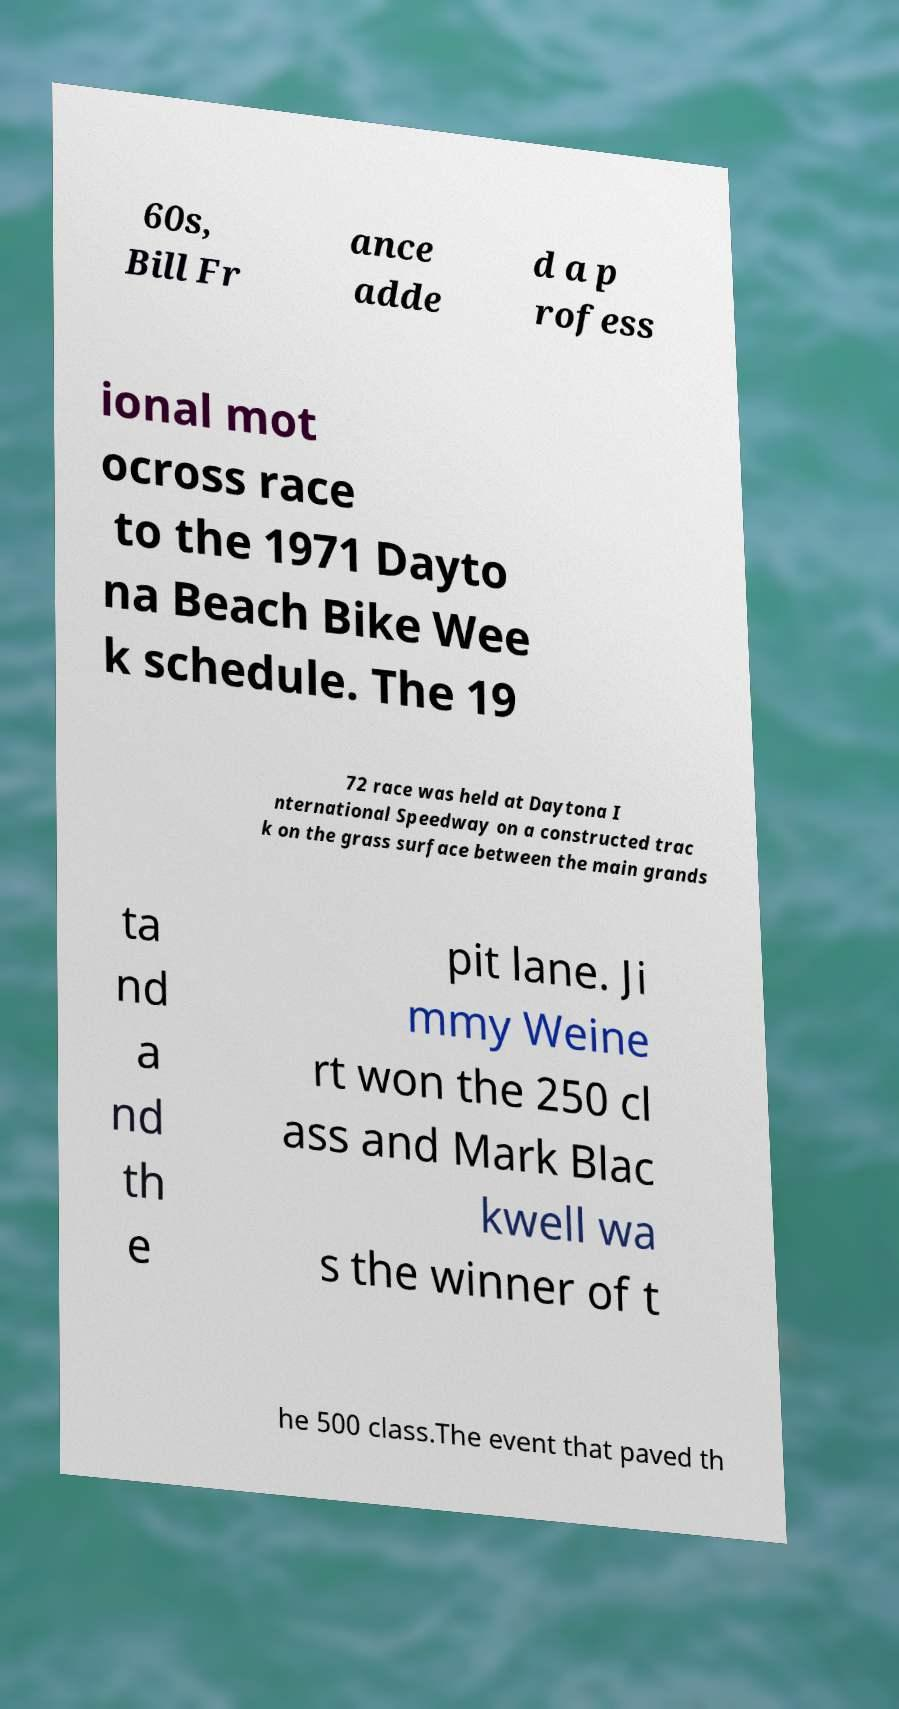For documentation purposes, I need the text within this image transcribed. Could you provide that? 60s, Bill Fr ance adde d a p rofess ional mot ocross race to the 1971 Dayto na Beach Bike Wee k schedule. The 19 72 race was held at Daytona I nternational Speedway on a constructed trac k on the grass surface between the main grands ta nd a nd th e pit lane. Ji mmy Weine rt won the 250 cl ass and Mark Blac kwell wa s the winner of t he 500 class.The event that paved th 